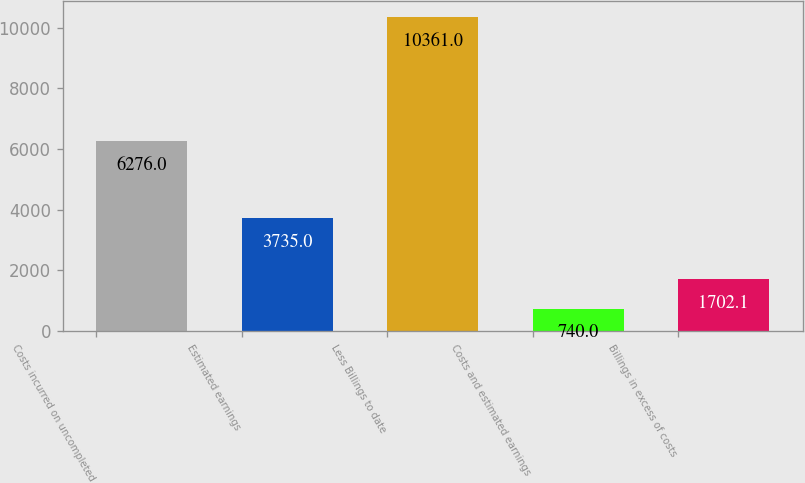<chart> <loc_0><loc_0><loc_500><loc_500><bar_chart><fcel>Costs incurred on uncompleted<fcel>Estimated earnings<fcel>Less Billings to date<fcel>Costs and estimated earnings<fcel>Billings in excess of costs<nl><fcel>6276<fcel>3735<fcel>10361<fcel>740<fcel>1702.1<nl></chart> 